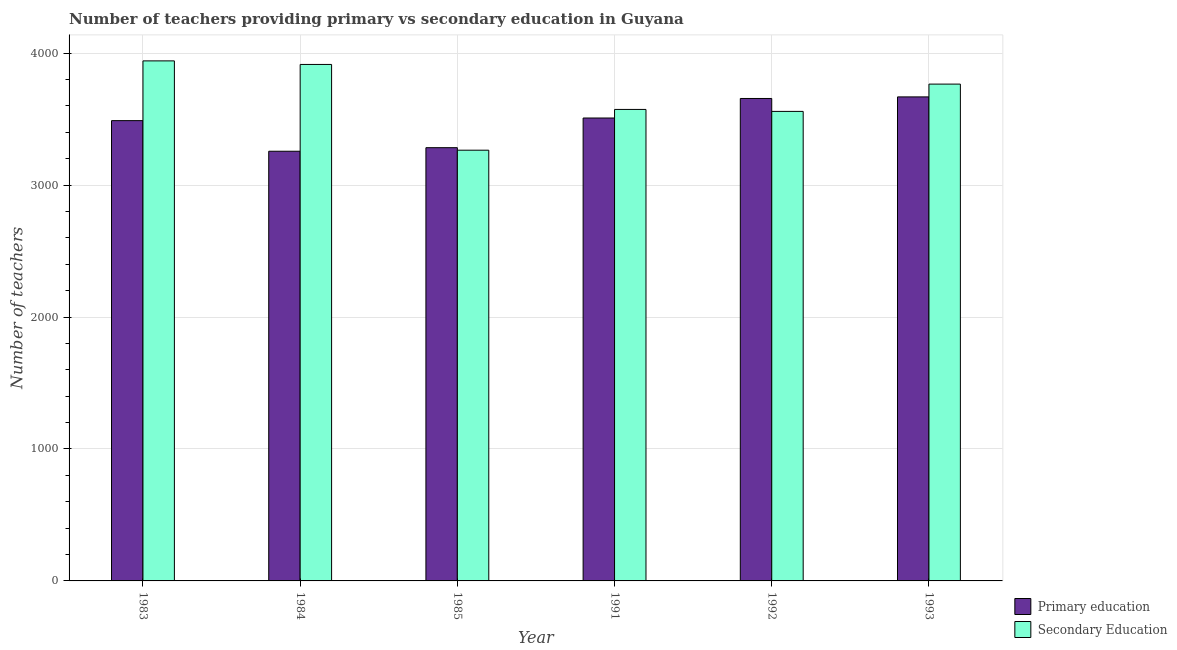How many different coloured bars are there?
Offer a very short reply. 2. What is the label of the 6th group of bars from the left?
Your response must be concise. 1993. What is the number of primary teachers in 1985?
Make the answer very short. 3284. Across all years, what is the maximum number of primary teachers?
Provide a succinct answer. 3669. Across all years, what is the minimum number of primary teachers?
Your response must be concise. 3257. What is the total number of primary teachers in the graph?
Your response must be concise. 2.09e+04. What is the difference between the number of primary teachers in 1983 and that in 1984?
Keep it short and to the point. 232. What is the difference between the number of secondary teachers in 1991 and the number of primary teachers in 1993?
Keep it short and to the point. -192. What is the average number of secondary teachers per year?
Provide a succinct answer. 3670.17. What is the ratio of the number of secondary teachers in 1983 to that in 1984?
Keep it short and to the point. 1.01. What is the difference between the highest and the lowest number of primary teachers?
Provide a succinct answer. 412. In how many years, is the number of secondary teachers greater than the average number of secondary teachers taken over all years?
Your answer should be very brief. 3. Is the sum of the number of secondary teachers in 1984 and 1993 greater than the maximum number of primary teachers across all years?
Your answer should be very brief. Yes. What does the 2nd bar from the left in 1991 represents?
Provide a short and direct response. Secondary Education. What does the 1st bar from the right in 1983 represents?
Your response must be concise. Secondary Education. How many years are there in the graph?
Offer a terse response. 6. Are the values on the major ticks of Y-axis written in scientific E-notation?
Your response must be concise. No. What is the title of the graph?
Your response must be concise. Number of teachers providing primary vs secondary education in Guyana. Does "Commercial bank branches" appear as one of the legend labels in the graph?
Your answer should be compact. No. What is the label or title of the Y-axis?
Give a very brief answer. Number of teachers. What is the Number of teachers in Primary education in 1983?
Provide a succinct answer. 3489. What is the Number of teachers of Secondary Education in 1983?
Your answer should be very brief. 3942. What is the Number of teachers in Primary education in 1984?
Provide a short and direct response. 3257. What is the Number of teachers in Secondary Education in 1984?
Offer a terse response. 3915. What is the Number of teachers in Primary education in 1985?
Your answer should be compact. 3284. What is the Number of teachers of Secondary Education in 1985?
Make the answer very short. 3265. What is the Number of teachers in Primary education in 1991?
Ensure brevity in your answer.  3509. What is the Number of teachers of Secondary Education in 1991?
Give a very brief answer. 3574. What is the Number of teachers in Primary education in 1992?
Keep it short and to the point. 3657. What is the Number of teachers of Secondary Education in 1992?
Your answer should be compact. 3559. What is the Number of teachers of Primary education in 1993?
Ensure brevity in your answer.  3669. What is the Number of teachers in Secondary Education in 1993?
Your answer should be compact. 3766. Across all years, what is the maximum Number of teachers in Primary education?
Offer a terse response. 3669. Across all years, what is the maximum Number of teachers of Secondary Education?
Your response must be concise. 3942. Across all years, what is the minimum Number of teachers in Primary education?
Ensure brevity in your answer.  3257. Across all years, what is the minimum Number of teachers of Secondary Education?
Ensure brevity in your answer.  3265. What is the total Number of teachers of Primary education in the graph?
Give a very brief answer. 2.09e+04. What is the total Number of teachers of Secondary Education in the graph?
Offer a terse response. 2.20e+04. What is the difference between the Number of teachers in Primary education in 1983 and that in 1984?
Make the answer very short. 232. What is the difference between the Number of teachers of Secondary Education in 1983 and that in 1984?
Provide a succinct answer. 27. What is the difference between the Number of teachers in Primary education in 1983 and that in 1985?
Your response must be concise. 205. What is the difference between the Number of teachers of Secondary Education in 1983 and that in 1985?
Make the answer very short. 677. What is the difference between the Number of teachers of Secondary Education in 1983 and that in 1991?
Provide a succinct answer. 368. What is the difference between the Number of teachers in Primary education in 1983 and that in 1992?
Make the answer very short. -168. What is the difference between the Number of teachers of Secondary Education in 1983 and that in 1992?
Ensure brevity in your answer.  383. What is the difference between the Number of teachers in Primary education in 1983 and that in 1993?
Offer a terse response. -180. What is the difference between the Number of teachers in Secondary Education in 1983 and that in 1993?
Provide a succinct answer. 176. What is the difference between the Number of teachers of Primary education in 1984 and that in 1985?
Ensure brevity in your answer.  -27. What is the difference between the Number of teachers of Secondary Education in 1984 and that in 1985?
Ensure brevity in your answer.  650. What is the difference between the Number of teachers of Primary education in 1984 and that in 1991?
Provide a short and direct response. -252. What is the difference between the Number of teachers of Secondary Education in 1984 and that in 1991?
Ensure brevity in your answer.  341. What is the difference between the Number of teachers in Primary education in 1984 and that in 1992?
Ensure brevity in your answer.  -400. What is the difference between the Number of teachers of Secondary Education in 1984 and that in 1992?
Provide a succinct answer. 356. What is the difference between the Number of teachers in Primary education in 1984 and that in 1993?
Provide a succinct answer. -412. What is the difference between the Number of teachers in Secondary Education in 1984 and that in 1993?
Give a very brief answer. 149. What is the difference between the Number of teachers in Primary education in 1985 and that in 1991?
Offer a very short reply. -225. What is the difference between the Number of teachers of Secondary Education in 1985 and that in 1991?
Keep it short and to the point. -309. What is the difference between the Number of teachers in Primary education in 1985 and that in 1992?
Give a very brief answer. -373. What is the difference between the Number of teachers in Secondary Education in 1985 and that in 1992?
Your answer should be very brief. -294. What is the difference between the Number of teachers in Primary education in 1985 and that in 1993?
Offer a terse response. -385. What is the difference between the Number of teachers of Secondary Education in 1985 and that in 1993?
Provide a short and direct response. -501. What is the difference between the Number of teachers in Primary education in 1991 and that in 1992?
Keep it short and to the point. -148. What is the difference between the Number of teachers in Secondary Education in 1991 and that in 1992?
Your response must be concise. 15. What is the difference between the Number of teachers of Primary education in 1991 and that in 1993?
Provide a succinct answer. -160. What is the difference between the Number of teachers of Secondary Education in 1991 and that in 1993?
Offer a very short reply. -192. What is the difference between the Number of teachers of Secondary Education in 1992 and that in 1993?
Provide a succinct answer. -207. What is the difference between the Number of teachers of Primary education in 1983 and the Number of teachers of Secondary Education in 1984?
Give a very brief answer. -426. What is the difference between the Number of teachers of Primary education in 1983 and the Number of teachers of Secondary Education in 1985?
Your answer should be compact. 224. What is the difference between the Number of teachers of Primary education in 1983 and the Number of teachers of Secondary Education in 1991?
Offer a terse response. -85. What is the difference between the Number of teachers in Primary education in 1983 and the Number of teachers in Secondary Education in 1992?
Your answer should be compact. -70. What is the difference between the Number of teachers in Primary education in 1983 and the Number of teachers in Secondary Education in 1993?
Offer a terse response. -277. What is the difference between the Number of teachers of Primary education in 1984 and the Number of teachers of Secondary Education in 1985?
Provide a succinct answer. -8. What is the difference between the Number of teachers in Primary education in 1984 and the Number of teachers in Secondary Education in 1991?
Keep it short and to the point. -317. What is the difference between the Number of teachers of Primary education in 1984 and the Number of teachers of Secondary Education in 1992?
Your answer should be very brief. -302. What is the difference between the Number of teachers of Primary education in 1984 and the Number of teachers of Secondary Education in 1993?
Your answer should be compact. -509. What is the difference between the Number of teachers of Primary education in 1985 and the Number of teachers of Secondary Education in 1991?
Offer a terse response. -290. What is the difference between the Number of teachers of Primary education in 1985 and the Number of teachers of Secondary Education in 1992?
Offer a terse response. -275. What is the difference between the Number of teachers of Primary education in 1985 and the Number of teachers of Secondary Education in 1993?
Provide a short and direct response. -482. What is the difference between the Number of teachers of Primary education in 1991 and the Number of teachers of Secondary Education in 1993?
Provide a succinct answer. -257. What is the difference between the Number of teachers of Primary education in 1992 and the Number of teachers of Secondary Education in 1993?
Make the answer very short. -109. What is the average Number of teachers of Primary education per year?
Provide a short and direct response. 3477.5. What is the average Number of teachers in Secondary Education per year?
Your answer should be compact. 3670.17. In the year 1983, what is the difference between the Number of teachers of Primary education and Number of teachers of Secondary Education?
Ensure brevity in your answer.  -453. In the year 1984, what is the difference between the Number of teachers in Primary education and Number of teachers in Secondary Education?
Your answer should be compact. -658. In the year 1985, what is the difference between the Number of teachers of Primary education and Number of teachers of Secondary Education?
Your response must be concise. 19. In the year 1991, what is the difference between the Number of teachers in Primary education and Number of teachers in Secondary Education?
Your response must be concise. -65. In the year 1992, what is the difference between the Number of teachers of Primary education and Number of teachers of Secondary Education?
Your answer should be compact. 98. In the year 1993, what is the difference between the Number of teachers of Primary education and Number of teachers of Secondary Education?
Ensure brevity in your answer.  -97. What is the ratio of the Number of teachers of Primary education in 1983 to that in 1984?
Ensure brevity in your answer.  1.07. What is the ratio of the Number of teachers of Primary education in 1983 to that in 1985?
Make the answer very short. 1.06. What is the ratio of the Number of teachers of Secondary Education in 1983 to that in 1985?
Make the answer very short. 1.21. What is the ratio of the Number of teachers in Primary education in 1983 to that in 1991?
Offer a very short reply. 0.99. What is the ratio of the Number of teachers of Secondary Education in 1983 to that in 1991?
Your answer should be very brief. 1.1. What is the ratio of the Number of teachers in Primary education in 1983 to that in 1992?
Provide a succinct answer. 0.95. What is the ratio of the Number of teachers of Secondary Education in 1983 to that in 1992?
Your answer should be compact. 1.11. What is the ratio of the Number of teachers in Primary education in 1983 to that in 1993?
Your answer should be compact. 0.95. What is the ratio of the Number of teachers in Secondary Education in 1983 to that in 1993?
Keep it short and to the point. 1.05. What is the ratio of the Number of teachers of Primary education in 1984 to that in 1985?
Provide a succinct answer. 0.99. What is the ratio of the Number of teachers of Secondary Education in 1984 to that in 1985?
Give a very brief answer. 1.2. What is the ratio of the Number of teachers of Primary education in 1984 to that in 1991?
Provide a short and direct response. 0.93. What is the ratio of the Number of teachers in Secondary Education in 1984 to that in 1991?
Keep it short and to the point. 1.1. What is the ratio of the Number of teachers of Primary education in 1984 to that in 1992?
Give a very brief answer. 0.89. What is the ratio of the Number of teachers in Primary education in 1984 to that in 1993?
Provide a succinct answer. 0.89. What is the ratio of the Number of teachers of Secondary Education in 1984 to that in 1993?
Provide a succinct answer. 1.04. What is the ratio of the Number of teachers in Primary education in 1985 to that in 1991?
Provide a short and direct response. 0.94. What is the ratio of the Number of teachers in Secondary Education in 1985 to that in 1991?
Offer a terse response. 0.91. What is the ratio of the Number of teachers in Primary education in 1985 to that in 1992?
Make the answer very short. 0.9. What is the ratio of the Number of teachers in Secondary Education in 1985 to that in 1992?
Give a very brief answer. 0.92. What is the ratio of the Number of teachers of Primary education in 1985 to that in 1993?
Your answer should be compact. 0.9. What is the ratio of the Number of teachers in Secondary Education in 1985 to that in 1993?
Provide a short and direct response. 0.87. What is the ratio of the Number of teachers of Primary education in 1991 to that in 1992?
Provide a short and direct response. 0.96. What is the ratio of the Number of teachers of Secondary Education in 1991 to that in 1992?
Give a very brief answer. 1. What is the ratio of the Number of teachers of Primary education in 1991 to that in 1993?
Your response must be concise. 0.96. What is the ratio of the Number of teachers of Secondary Education in 1991 to that in 1993?
Make the answer very short. 0.95. What is the ratio of the Number of teachers of Secondary Education in 1992 to that in 1993?
Offer a very short reply. 0.94. What is the difference between the highest and the lowest Number of teachers of Primary education?
Make the answer very short. 412. What is the difference between the highest and the lowest Number of teachers of Secondary Education?
Keep it short and to the point. 677. 